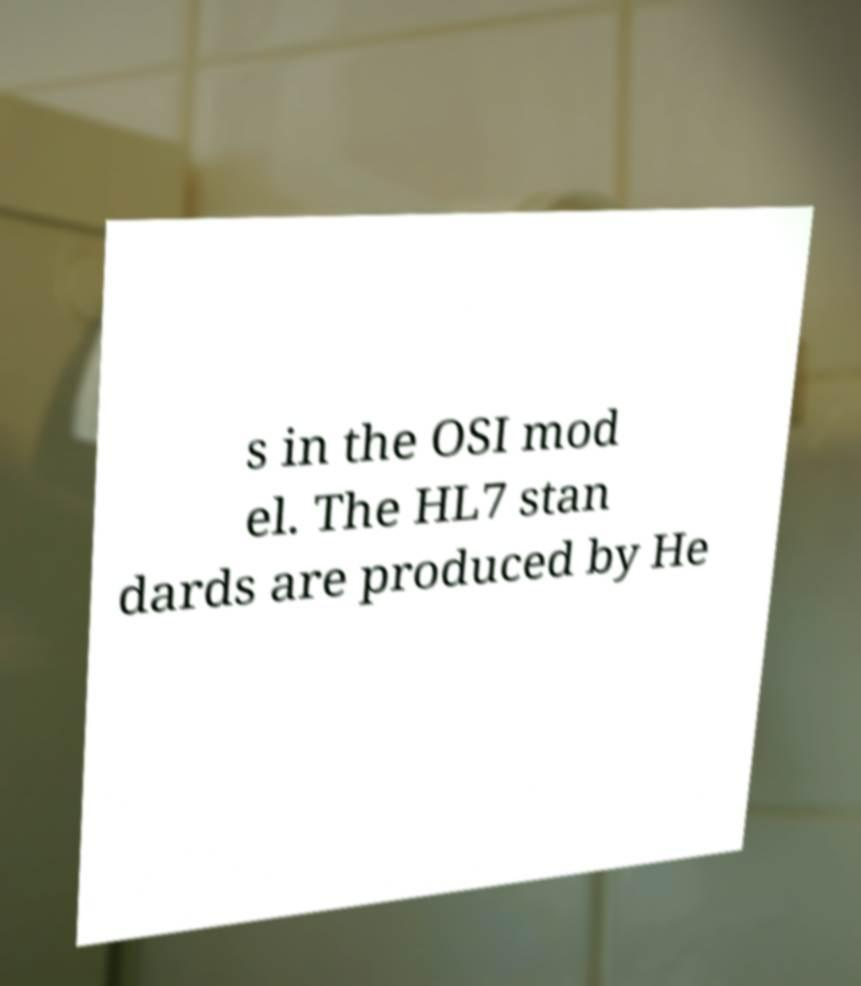Could you extract and type out the text from this image? s in the OSI mod el. The HL7 stan dards are produced by He 